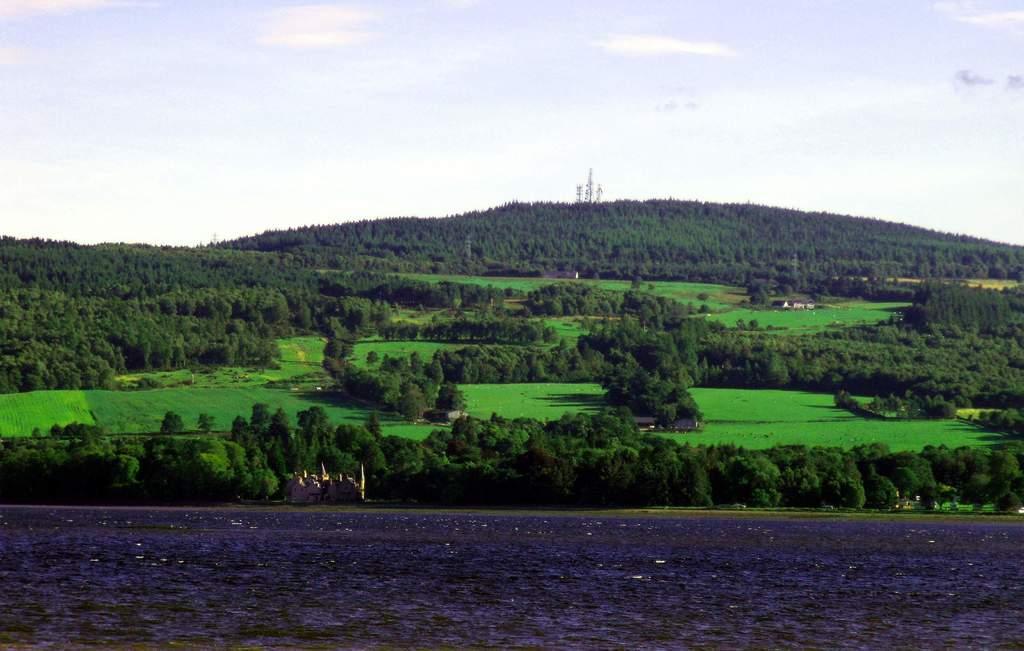How would you summarize this image in a sentence or two? In this image we can see trees, plants, grass, house, towers, castle and water. In the background we can see sky and clouds. 